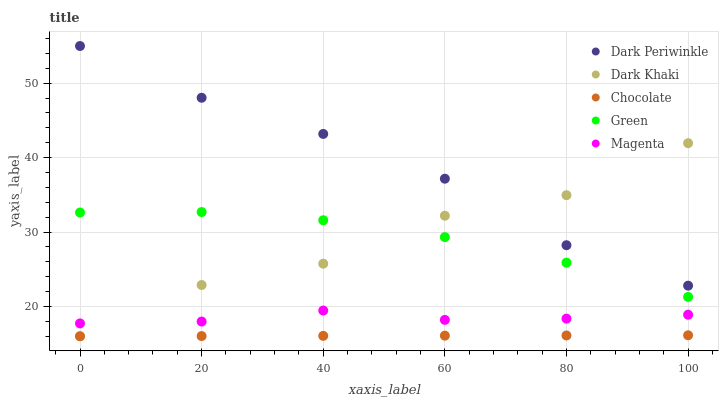Does Chocolate have the minimum area under the curve?
Answer yes or no. Yes. Does Dark Periwinkle have the maximum area under the curve?
Answer yes or no. Yes. Does Magenta have the minimum area under the curve?
Answer yes or no. No. Does Magenta have the maximum area under the curve?
Answer yes or no. No. Is Chocolate the smoothest?
Answer yes or no. Yes. Is Dark Khaki the roughest?
Answer yes or no. Yes. Is Magenta the smoothest?
Answer yes or no. No. Is Magenta the roughest?
Answer yes or no. No. Does Dark Khaki have the lowest value?
Answer yes or no. Yes. Does Magenta have the lowest value?
Answer yes or no. No. Does Dark Periwinkle have the highest value?
Answer yes or no. Yes. Does Magenta have the highest value?
Answer yes or no. No. Is Chocolate less than Dark Periwinkle?
Answer yes or no. Yes. Is Green greater than Chocolate?
Answer yes or no. Yes. Does Dark Periwinkle intersect Dark Khaki?
Answer yes or no. Yes. Is Dark Periwinkle less than Dark Khaki?
Answer yes or no. No. Is Dark Periwinkle greater than Dark Khaki?
Answer yes or no. No. Does Chocolate intersect Dark Periwinkle?
Answer yes or no. No. 